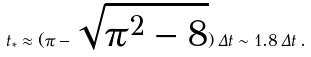<formula> <loc_0><loc_0><loc_500><loc_500>t _ { * } \approx ( \pi - \sqrt { \pi ^ { 2 } - 8 } ) \, \Delta t \sim 1 . 8 \, \Delta t \, .</formula> 